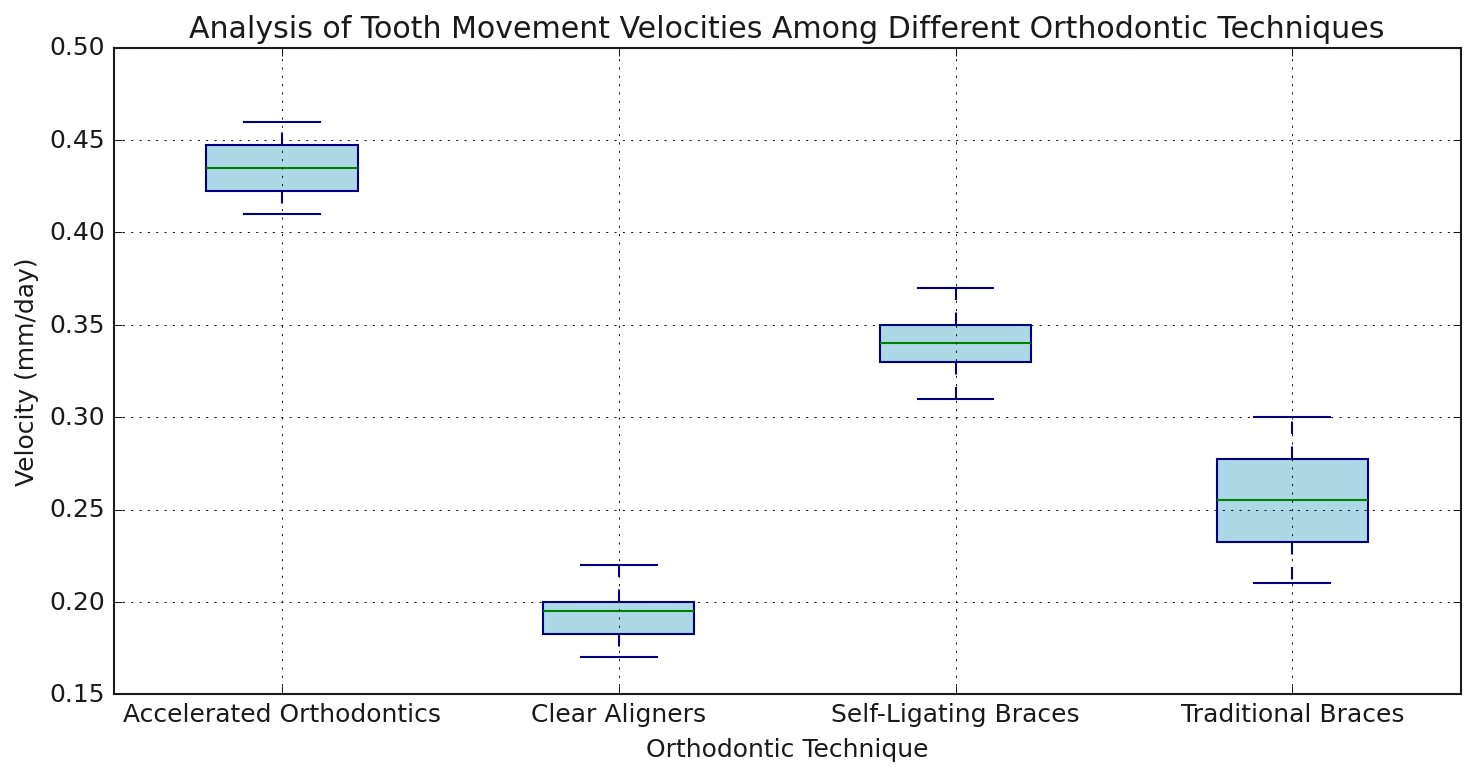Which orthodontic technique has the highest median velocity? First, identify the median lines within the box for each technique on the plot. The median line within the box representing Accelerated Orthodontics is the highest amongst all techniques, indicating it has the highest median velocity.
Answer: Accelerated Orthodontics What is the approximate median velocity for Clear Aligners? Look at the median line inside the box of the Clear Aligners box plot, which represents the median velocity. It's located around 0.20 (mm/day).
Answer: 0.20 (mm/day) Which technique shows the greatest variation in velocity? Compare the length of the boxes and whiskers for each technique. Traditional Braces appear to have the longest range from the top to bottom whiskers, signaling the greatest variation in velocity.
Answer: Traditional Braces Is the median velocity of Self-Ligating Braces higher than that of Traditional Braces? Observe the median lines within the boxes for both techniques. The median line for Self-Ligating Braces lies higher than that for Traditional Braces.
Answer: Yes Which technique has the most concentrated velocities (smallest interquartile range)? Find the technique whose box (excluding whiskers) is the shortest. Clear Aligners have the smallest box, indicating the most concentrated velocities.
Answer: Clear Aligners What is the approximate interquartile range (IQR) for Accelerated Orthodontics? The IQR is the length of the box in the box plot. For Accelerated Orthodontics, the lower quartile is around 0.42 and the upper quartile around 0.45. Subtract the lower quartile value from the upper quartile value to get the IQR: 0.45 - 0.42.
Answer: 0.03 (mm/day) Compare the median velocities of Traditional Braces and Accelerated Orthodontics; which one is higher and by how much? Identify the median lines for both techniques. The median for Traditional Braces is approximately 0.25, and for Accelerated Orthodontics, it's about 0.44. The difference is 0.44 - 0.25.
Answer: Accelerated Orthodontics by 0.19 (mm/day) Are there any outliers in any of the techniques? Outliers are typically visible as individual points outside the whiskers. None of the techniques exhibit outliers in the given box plots.
Answer: No Which orthodontic technique shows the lowest maximum velocity, and what is its approximate value? Look at the top whisker ends for each technique. Clear Aligners have the lowest top whisker end, at around 0.22.
Answer: Clear Aligners, 0.22 (mm/day) For Traditional Braces, estimate the range between the minimum and maximum velocities. Identify the bottom and top whiskers' ends for Traditional Braces. The minimum velocity is around 0.21, and the maximum is around 0.30. Subtract the minimum from the maximum: 0.30 - 0.21.
Answer: 0.09 (mm/day) 